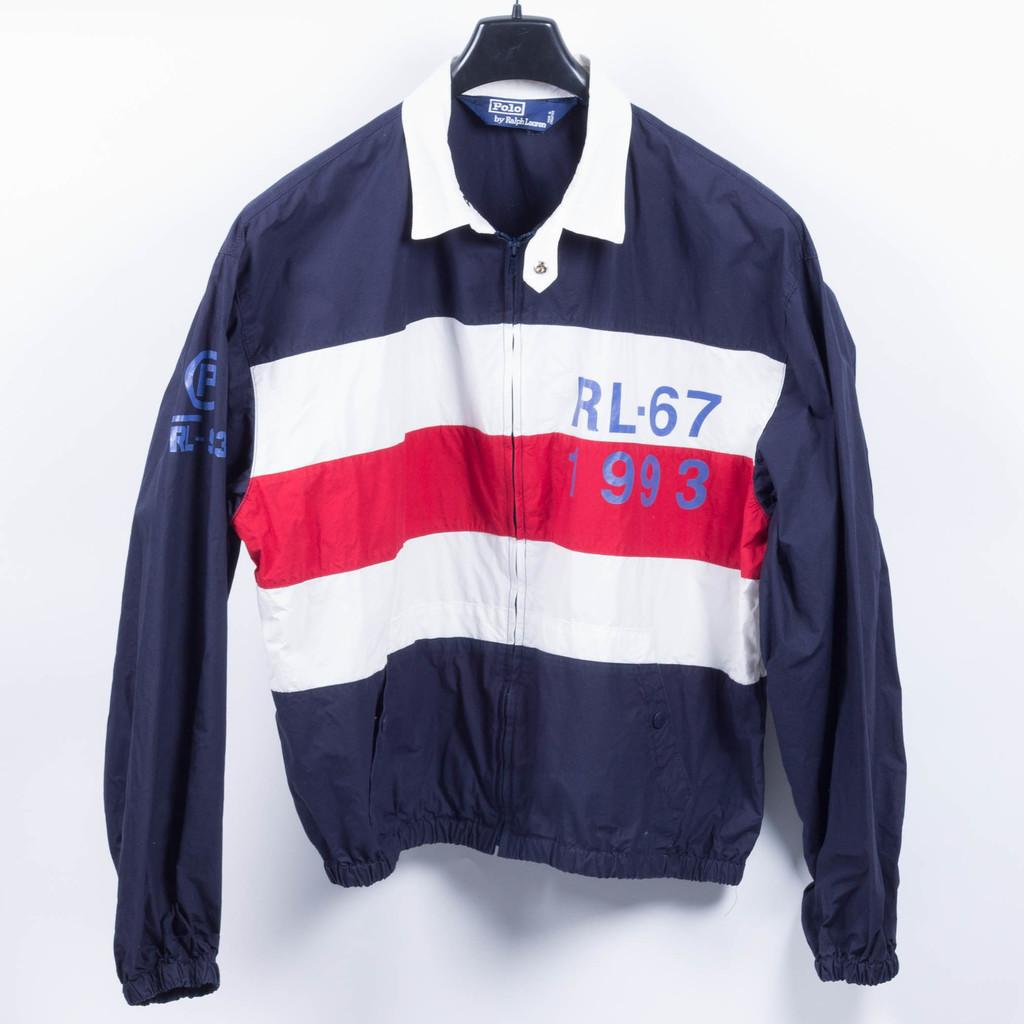<image>
Present a compact description of the photo's key features. A Blue,red and white jacket made by Polo. 